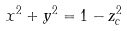Convert formula to latex. <formula><loc_0><loc_0><loc_500><loc_500>x ^ { 2 } + y ^ { 2 } = 1 - z _ { c } ^ { 2 }</formula> 